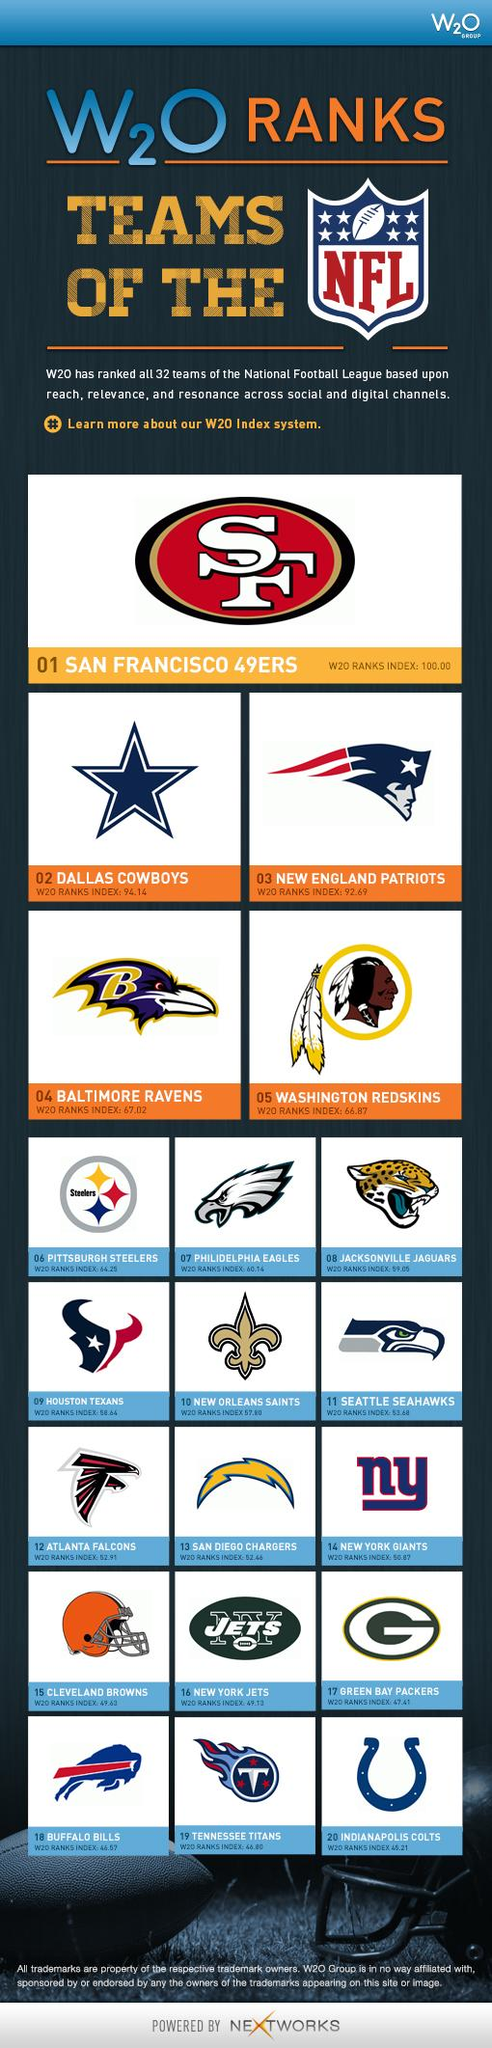Draw attention to some important aspects in this diagram. There are 32 NFL teams. Indianapolis Colts have the lowest W20 rank index among all NFL teams. The Dallas Cowboys have the second-highest W20 rank index among all NFL teams, according to the latest rankings. 